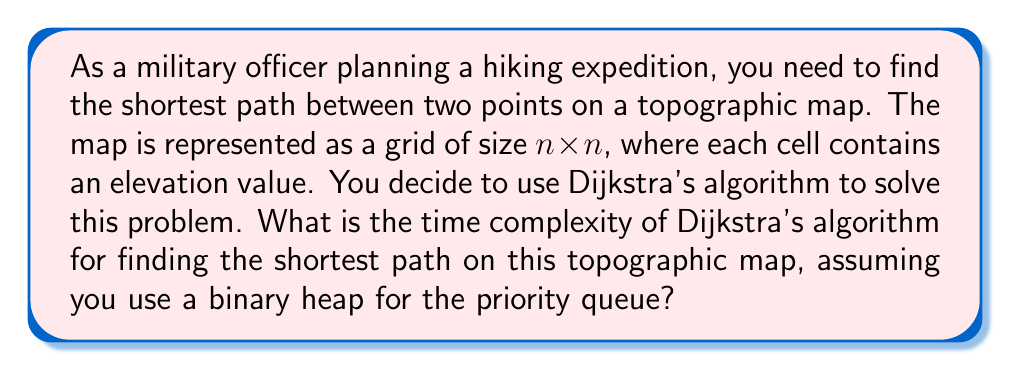What is the answer to this math problem? To analyze the time complexity of Dijkstra's algorithm for this scenario, let's break down the problem and the algorithm:

1. The topographic map is represented as a grid of size $n \times n$, so there are $N = n^2$ total vertices (cells) in the graph.

2. Each cell can be connected to at most 4 neighboring cells (up, down, left, right), so the total number of edges is at most $4N = 4n^2$.

3. Dijkstra's algorithm with a binary heap implementation has the following operations:
   a. Insert vertices into the heap: $O(\log N)$ per insertion
   b. Extract minimum from the heap: $O(\log N)$ per extraction
   c. Update distances: $O(\log N)$ per update

4. In the worst case, we will:
   a. Insert all $N$ vertices into the heap: $N \cdot O(\log N)$
   b. Extract the minimum $N$ times: $N \cdot O(\log N)$
   c. Update distances for each edge: $4N \cdot O(\log N)$

5. The total time complexity is the sum of these operations:
   $T(N) = N \cdot O(\log N) + N \cdot O(\log N) + 4N \cdot O(\log N)$
   $T(N) = 6N \cdot O(\log N)$

6. Simplifying and expressing in terms of $n$:
   $T(n^2) = 6n^2 \cdot O(\log(n^2))$
   $T(n^2) = 6n^2 \cdot O(2\log n)$
   $T(n^2) = O(n^2 \log n)$

Therefore, the time complexity of Dijkstra's algorithm for finding the shortest path on this topographic map, using a binary heap for the priority queue, is $O(n^2 \log n)$.
Answer: $O(n^2 \log n)$ 